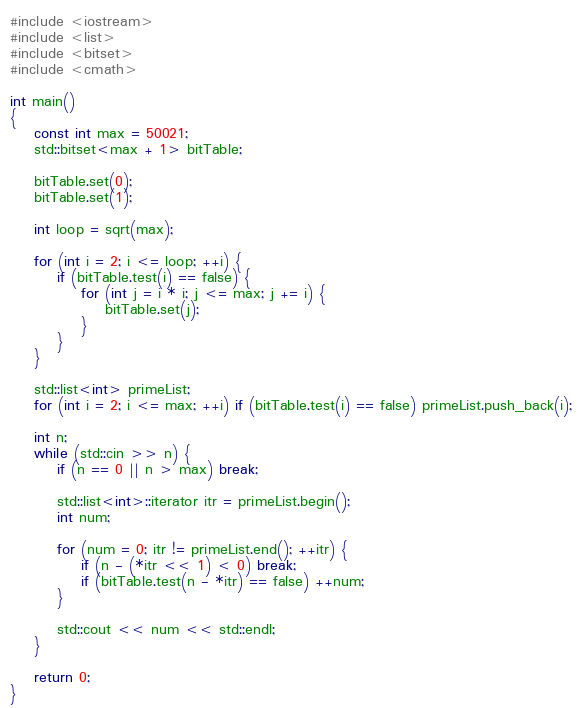<code> <loc_0><loc_0><loc_500><loc_500><_C++_>#include <iostream>
#include <list>
#include <bitset>
#include <cmath>

int main()
{
	const int max = 50021;
	std::bitset<max + 1> bitTable;
	
	bitTable.set(0);
	bitTable.set(1);
	
	int loop = sqrt(max);
	
	for (int i = 2; i <= loop; ++i) {
		if (bitTable.test(i) == false) {
			for (int j = i * i; j <= max; j += i) {
				bitTable.set(j);
			}
		}
	}
	
	std::list<int> primeList;
	for (int i = 2; i <= max; ++i) if (bitTable.test(i) == false) primeList.push_back(i);
	
	int n;
	while (std::cin >> n) {
		if (n == 0 || n > max) break;
		
		std::list<int>::iterator itr = primeList.begin();
		int num;
		
		for (num = 0; itr != primeList.end(); ++itr) {
			if (n - (*itr << 1) < 0) break;
			if (bitTable.test(n - *itr) == false) ++num;
		}
		
		std::cout << num << std::endl;
	}
	
	return 0;
}</code> 